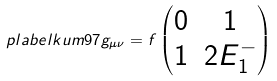<formula> <loc_0><loc_0><loc_500><loc_500>\ p l a b e l { k u m 9 7 } g _ { \mu \nu } = f \begin{pmatrix} 0 & 1 \\ 1 & 2 E _ { 1 } ^ { - } \end{pmatrix}</formula> 